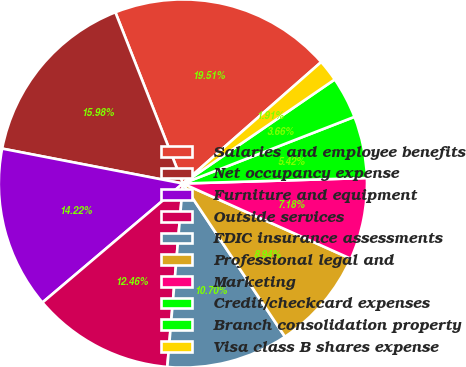<chart> <loc_0><loc_0><loc_500><loc_500><pie_chart><fcel>Salaries and employee benefits<fcel>Net occupancy expense<fcel>Furniture and equipment<fcel>Outside services<fcel>FDIC insurance assessments<fcel>Professional legal and<fcel>Marketing<fcel>Credit/checkcard expenses<fcel>Branch consolidation property<fcel>Visa class B shares expense<nl><fcel>19.5%<fcel>15.98%<fcel>14.22%<fcel>12.46%<fcel>10.7%<fcel>8.94%<fcel>7.18%<fcel>5.42%<fcel>3.66%<fcel>1.91%<nl></chart> 